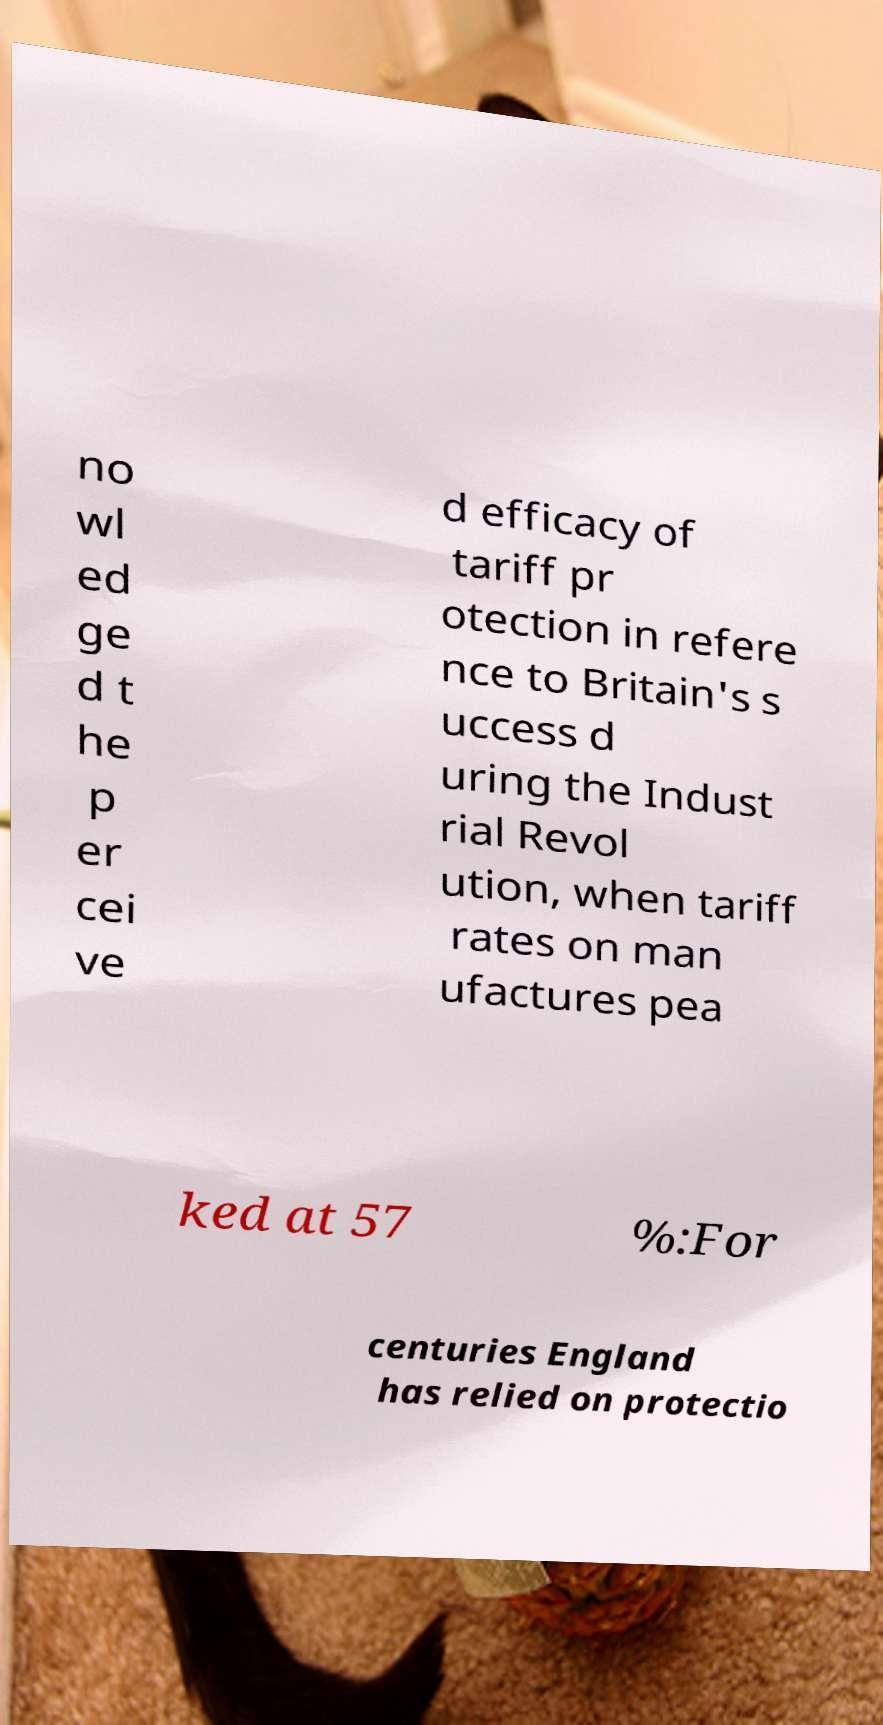Can you accurately transcribe the text from the provided image for me? no wl ed ge d t he p er cei ve d efficacy of tariff pr otection in refere nce to Britain's s uccess d uring the Indust rial Revol ution, when tariff rates on man ufactures pea ked at 57 %:For centuries England has relied on protectio 